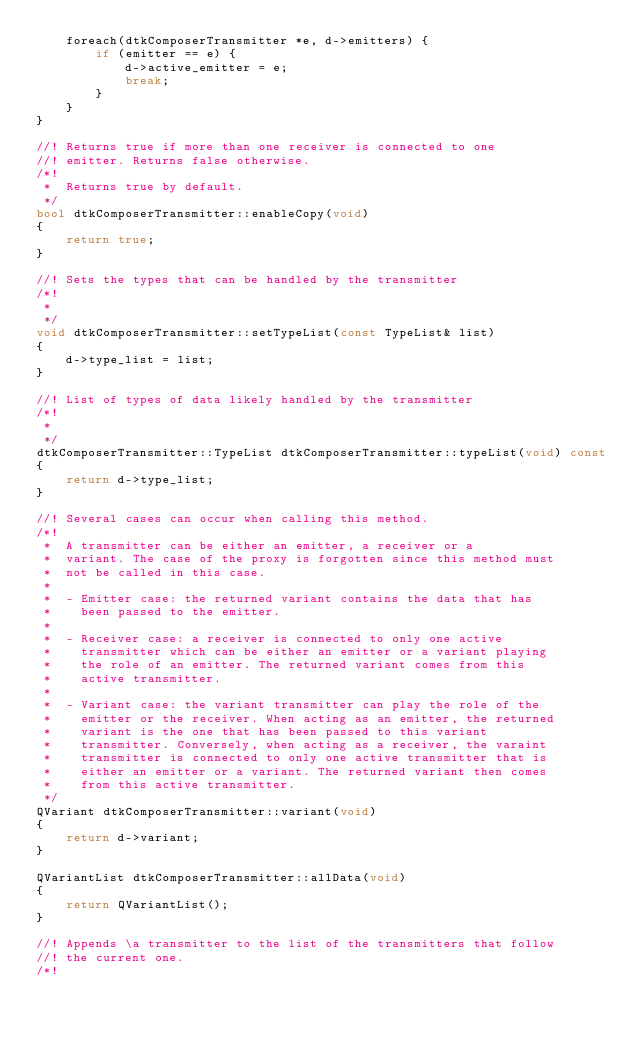Convert code to text. <code><loc_0><loc_0><loc_500><loc_500><_C++_>    foreach(dtkComposerTransmitter *e, d->emitters) {
        if (emitter == e) {
            d->active_emitter = e;
            break;
        }
    }
}

//! Returns true if more than one receiver is connected to one
//! emitter. Returns false otherwise.
/*! 
 *  Returns true by default.
 */
bool dtkComposerTransmitter::enableCopy(void)
{
    return true;
}

//! Sets the types that can be handled by the transmitter 
/*!  
 *  
 */
void dtkComposerTransmitter::setTypeList(const TypeList& list)
{
    d->type_list = list;
}

//! List of types of data likely handled by the transmitter 
/*!  
 *  
 */
dtkComposerTransmitter::TypeList dtkComposerTransmitter::typeList(void) const
{
    return d->type_list;
}

//! Several cases can occur when calling this method.
/*!  
 *  A transmitter can be either an emitter, a receiver or a
 *  variant. The case of the proxy is forgotten since this method must
 *  not be called in this case.
 *
 *  - Emitter case: the returned variant contains the data that has
 *    been passed to the emitter.
 *
 *  - Receiver case: a receiver is connected to only one active
 *    transmitter which can be either an emitter or a variant playing
 *    the role of an emitter. The returned variant comes from this
 *    active transmitter.
 *
 *  - Variant case: the variant transmitter can play the role of the
 *    emitter or the receiver. When acting as an emitter, the returned
 *    variant is the one that has been passed to this variant
 *    transmitter. Conversely, when acting as a receiver, the varaint
 *    transmitter is connected to only one active transmitter that is
 *    either an emitter or a variant. The returned variant then comes
 *    from this active transmitter.
 */
QVariant dtkComposerTransmitter::variant(void)
{
    return d->variant;
}

QVariantList dtkComposerTransmitter::allData(void)
{
    return QVariantList();
}

//! Appends \a transmitter to the list of the transmitters that follow
//! the current one. 
/*! </code> 